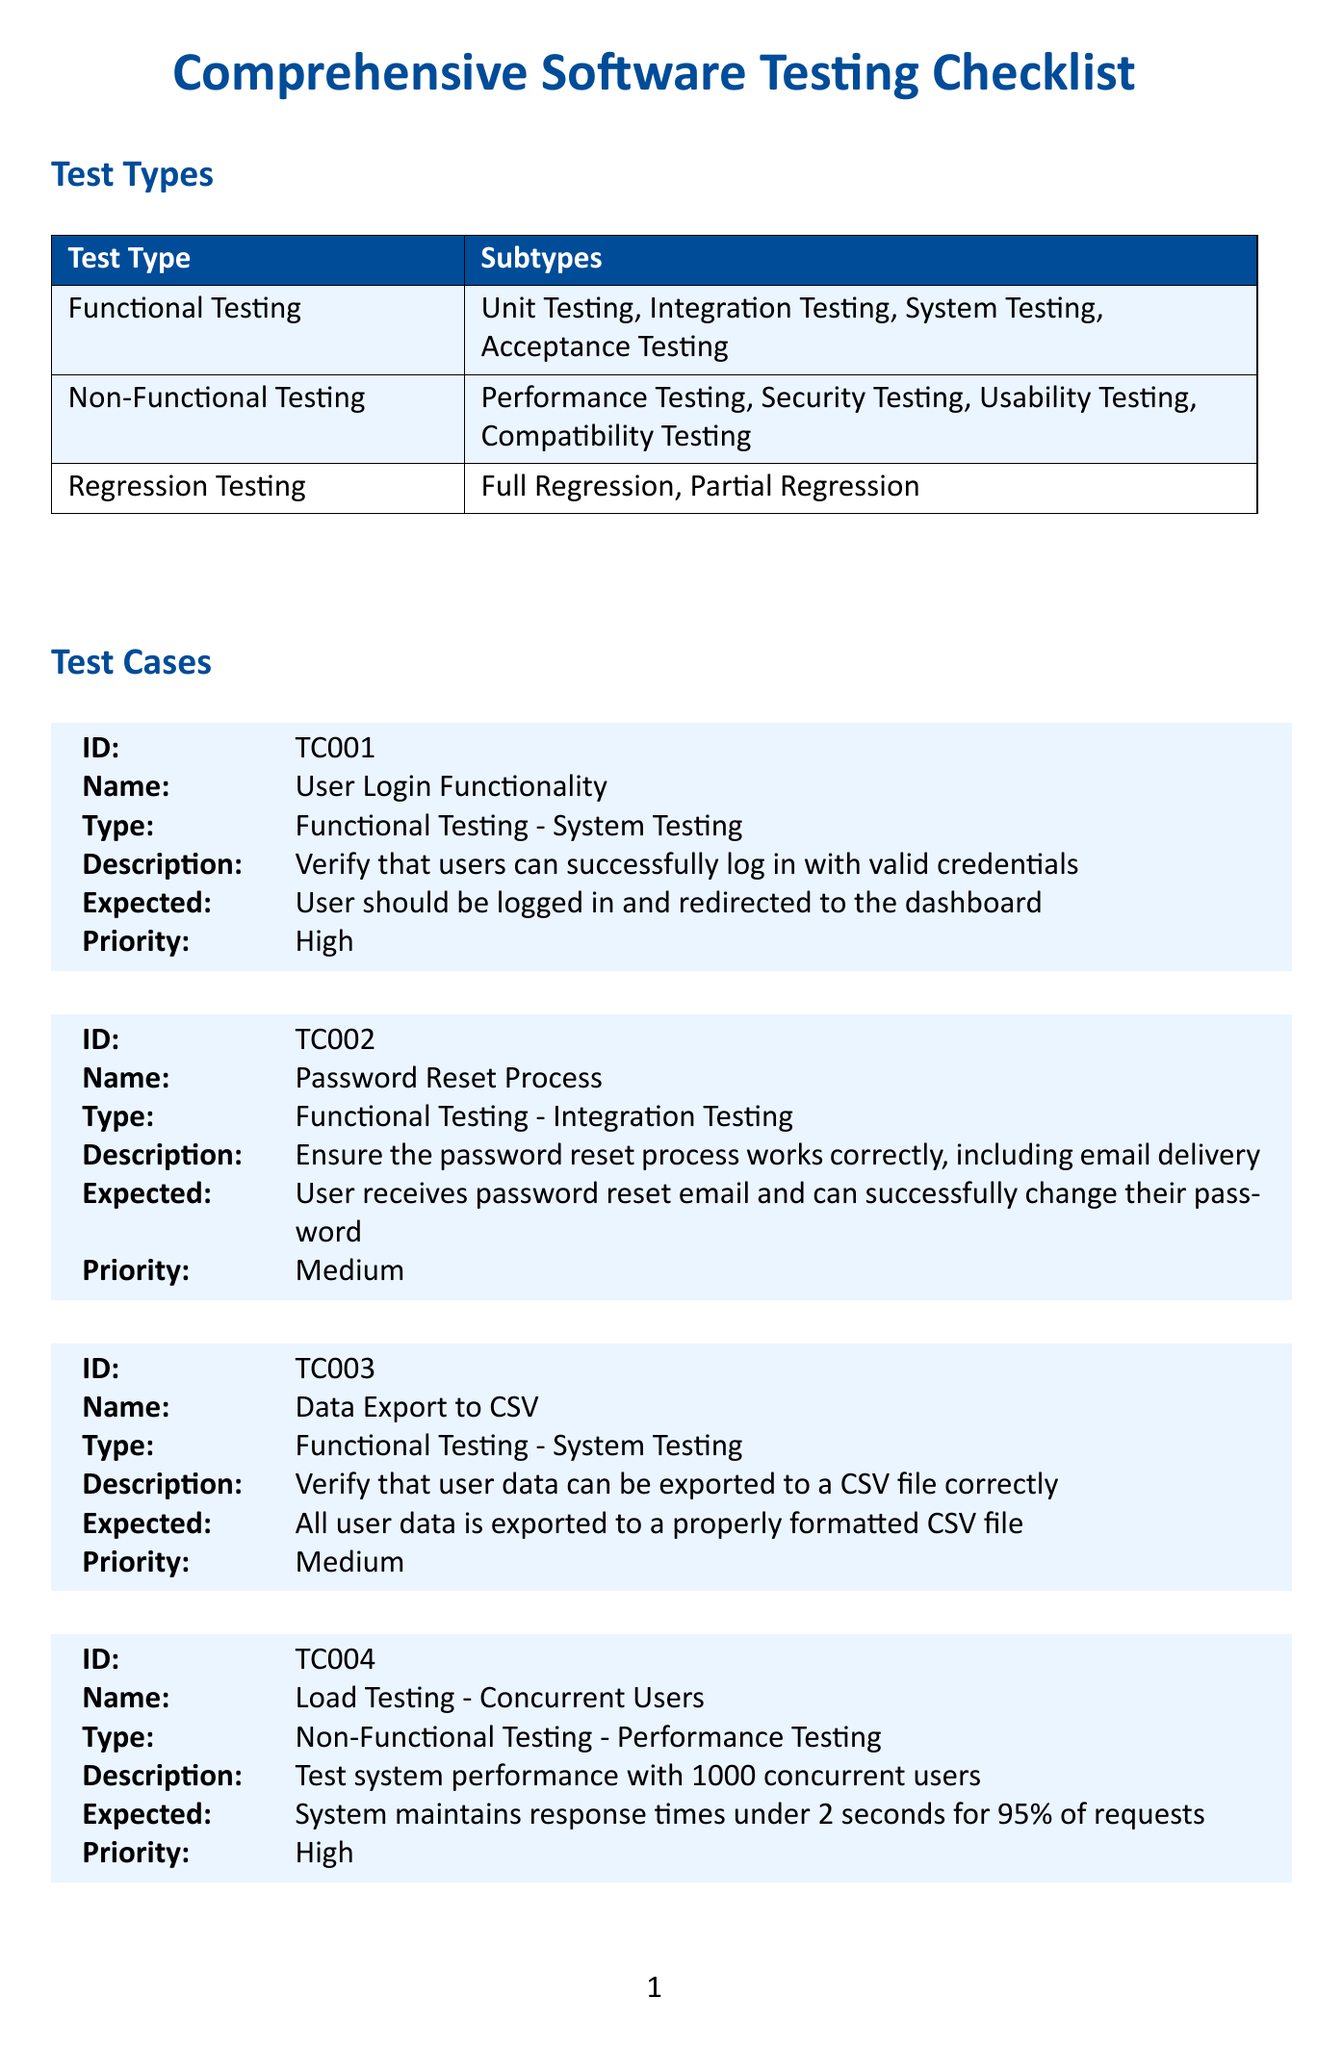What is the title of the document? The title of the document is presented prominently at the beginning, indicating the purpose of the form.
Answer: Comprehensive Software Testing Checklist How many test types are listed? The document includes a section that categorizes the various testing methods used, which can be counted.
Answer: 3 What is the expected result for the "User Login Functionality" test case? Each test case includes an expected outcome that describes the desired result after testing.
Answer: User should be logged in and redirected to the dashboard Who is responsible for testing? The document lists individuals assigned to testing activities, which indicates the team involved in the testing process.
Answer: John Smith, Emily Johnson, Michael Chen, Sarah Rodriguez What is the priority level of the "Cross-Site Scripting (XSS) Prevention" test case? Each test case is categorized with a priority level, indicating its importance in the testing process.
Answer: Critical Which test case type does "Mobile Responsiveness" belong to? The test case is categorized under the appropriate testing type based on its nature and purpose in the checklist.
Answer: Non-Functional Testing What is the highest priority among the stakeholder notes? The notes in the document include important considerations for the testing process, which can be assessed for priority.
Answer: Ensure all critical and high-priority test cases pass before considering the release How many test environments are mentioned? The document specifies the various environments in which testing occurs, allowing for easy counting.
Answer: 3 